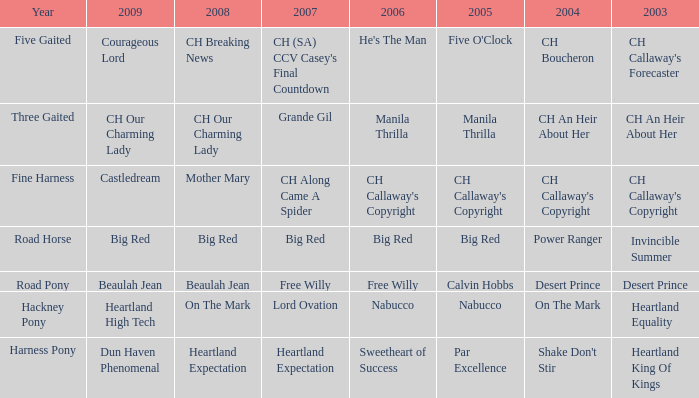Could you parse the entire table as a dict? {'header': ['Year', '2009', '2008', '2007', '2006', '2005', '2004', '2003'], 'rows': [['Five Gaited', 'Courageous Lord', 'CH Breaking News', "CH (SA) CCV Casey's Final Countdown", "He's The Man", "Five O'Clock", 'CH Boucheron', "CH Callaway's Forecaster"], ['Three Gaited', 'CH Our Charming Lady', 'CH Our Charming Lady', 'Grande Gil', 'Manila Thrilla', 'Manila Thrilla', 'CH An Heir About Her', 'CH An Heir About Her'], ['Fine Harness', 'Castledream', 'Mother Mary', 'CH Along Came A Spider', "CH Callaway's Copyright", "CH Callaway's Copyright", "CH Callaway's Copyright", "CH Callaway's Copyright"], ['Road Horse', 'Big Red', 'Big Red', 'Big Red', 'Big Red', 'Big Red', 'Power Ranger', 'Invincible Summer'], ['Road Pony', 'Beaulah Jean', 'Beaulah Jean', 'Free Willy', 'Free Willy', 'Calvin Hobbs', 'Desert Prince', 'Desert Prince'], ['Hackney Pony', 'Heartland High Tech', 'On The Mark', 'Lord Ovation', 'Nabucco', 'Nabucco', 'On The Mark', 'Heartland Equality'], ['Harness Pony', 'Dun Haven Phenomenal', 'Heartland Expectation', 'Heartland Expectation', 'Sweetheart of Success', 'Par Excellence', "Shake Don't Stir", 'Heartland King Of Kings']]} What is the 2008 for the 2009 ch our charming lady? CH Our Charming Lady. 